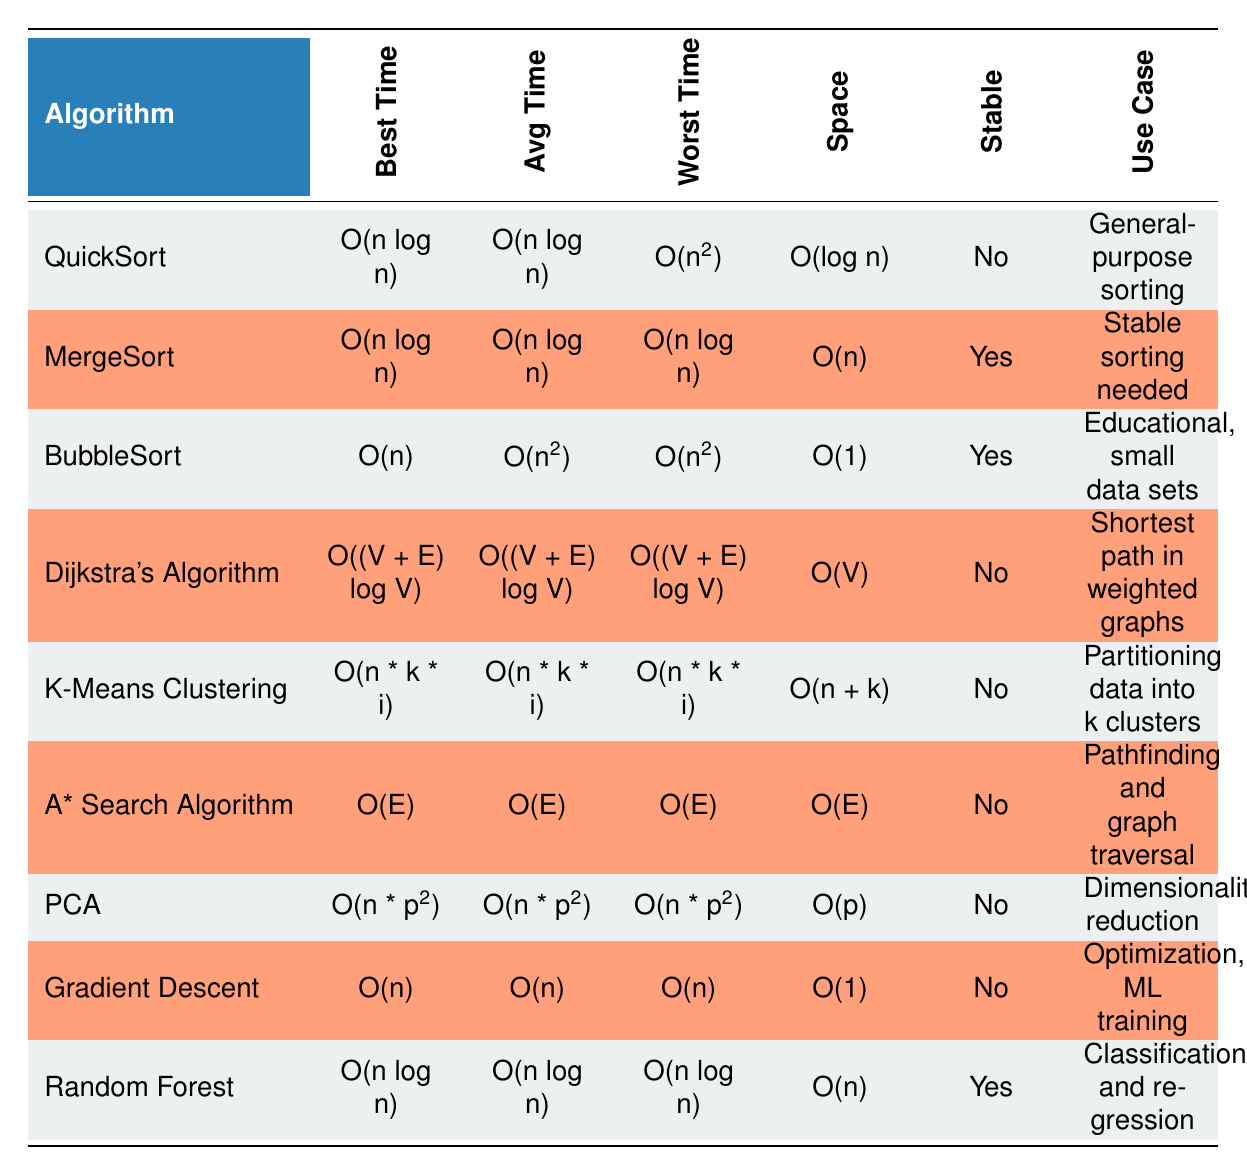What is the worst-case time complexity of QuickSort? By scanning the row for QuickSort in the table, the value under the "Worst Time" column is O(n^2).
Answer: O(n^2) Which sorting algorithm has the best space complexity? BubbleSort has the best space complexity in the table, marked as O(1), which is better than others like MergeSort (O(n)) or QuickSort (O(log n)).
Answer: BubbleSort Is MergeSort stable? Looking at the "Stable" column for MergeSort, the value is Yes, indicating it preserves the order of equal elements.
Answer: Yes What is the average time complexity of Dijkstra's Algorithm? The average time complexity for Dijkstra's Algorithm is indicated under the "Avg Time" column, which shows O((V + E) log V).
Answer: O((V + E) log V) How does the space complexity of Random Forest compare to that of K-Means Clustering? The space complexity of Random Forest is O(n) while K-Means Clustering has O(n + k). Since "n + k" is greater than "n" for any positive k, K-Means Clustering requires more space.
Answer: K-Means Clustering requires more space Which algorithms are suitable for educational purposes and small datasets? For educational purposes and small datasets, the algorithm indicated in the "Use Case" of the table is BubbleSort.
Answer: BubbleSort What is the average time complexity of algorithms used for graph traversal? The algorithms associated with graph traversal, A* Search Algorithm and Dijkstra's Algorithm, both have average time complexities of O(E) and O((V + E) log V), respectively. Hence, their average complexities differ.
Answer: O(E) and O((V + E) log V) Which algorithms can be used for optimization? The only algorithm listed for optimization in the table is Gradient Descent, as indicated under the "Use Case" column.
Answer: Gradient Descent Which algorithm provides a stable sorting mechanism and has a worst-case time complexity of O(n log n)? MergeSort is stable (Yes), and its worst-case time complexity is O(n log n), as seen in the corresponding columns.
Answer: MergeSort 